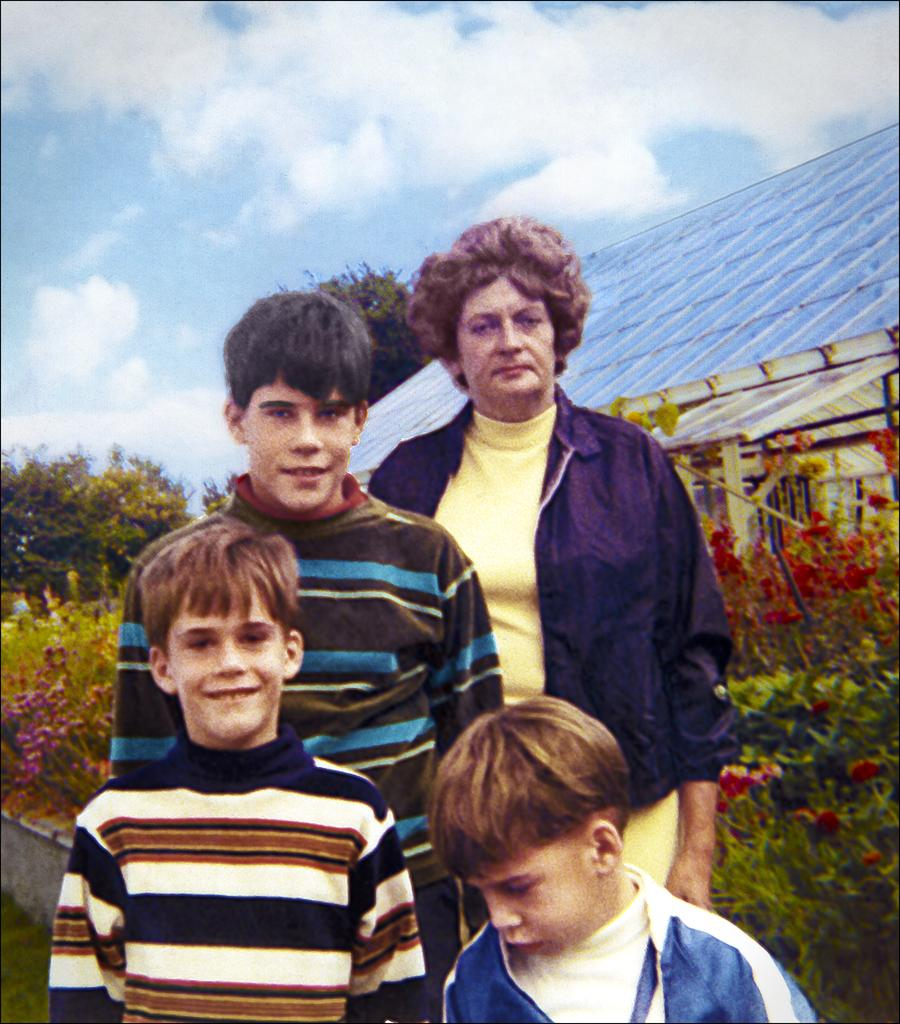What is the main subject of the image? There is a painting in the image. What is depicted in the painting? The painting depicts three boys and a woman. What are the people in the painting doing? The people in the painting are posing for the camera. What expressions do the people in the painting have? The people in the painting are smiling. What can be seen in the background of the painting? There are trees and a house behind the people in the painting. What type of dress is the woman wearing in the cemetery in the image? There is no cemetery present in the image, and the woman in the painting is not wearing a dress. 